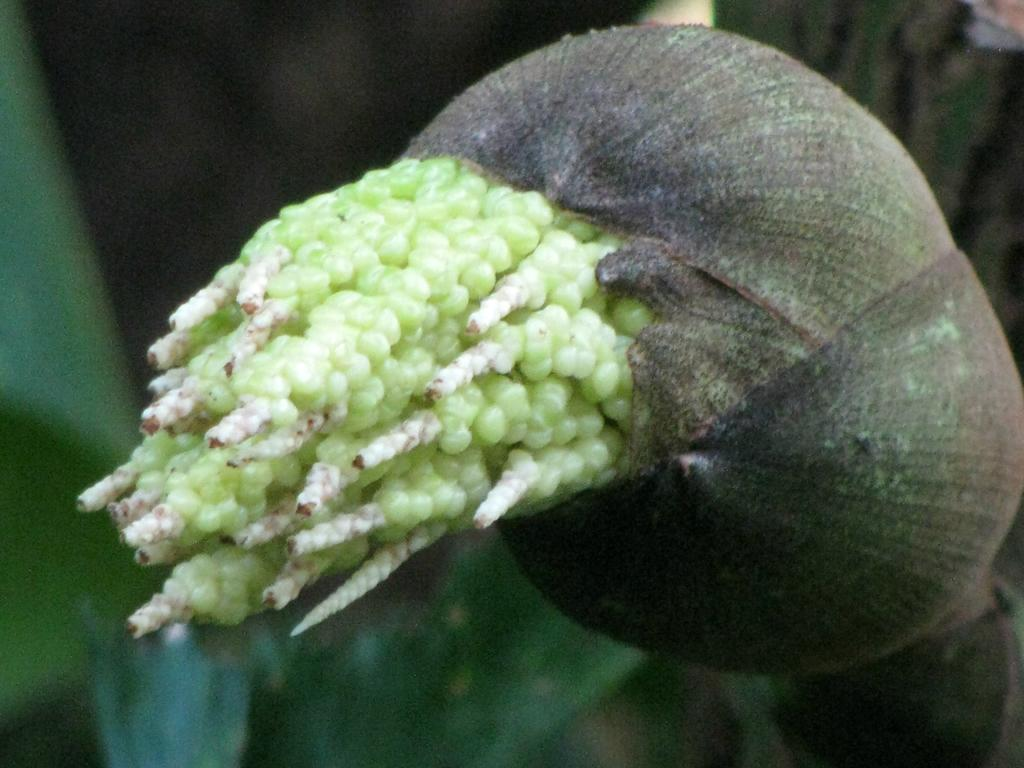What is coming out of the bag in the image? There are seeds coming out of a bag in the image. What is the purpose of these seeds? The seeds are associated with a tree. What else can be seen in the image besides the seeds and the bag? There are leaves visible in the image. Are there any fairies playing in the shade of the tree in the image? There is no mention of fairies or shade in the image; it only shows seeds coming out of a bag and leaves. 